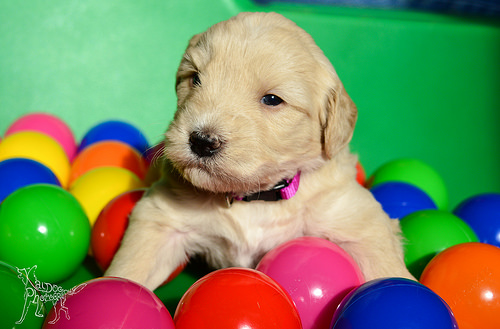<image>
Is the puppy above the ball? No. The puppy is not positioned above the ball. The vertical arrangement shows a different relationship. 